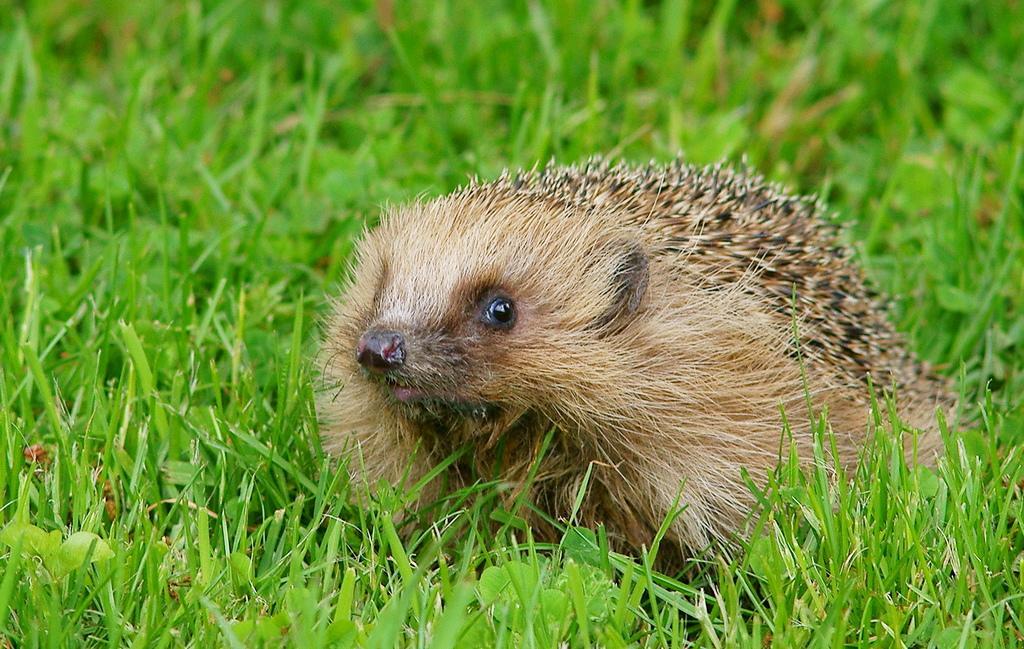Could you give a brief overview of what you see in this image? In this picture there is an animal on the grass and the animal is in light brown color. 